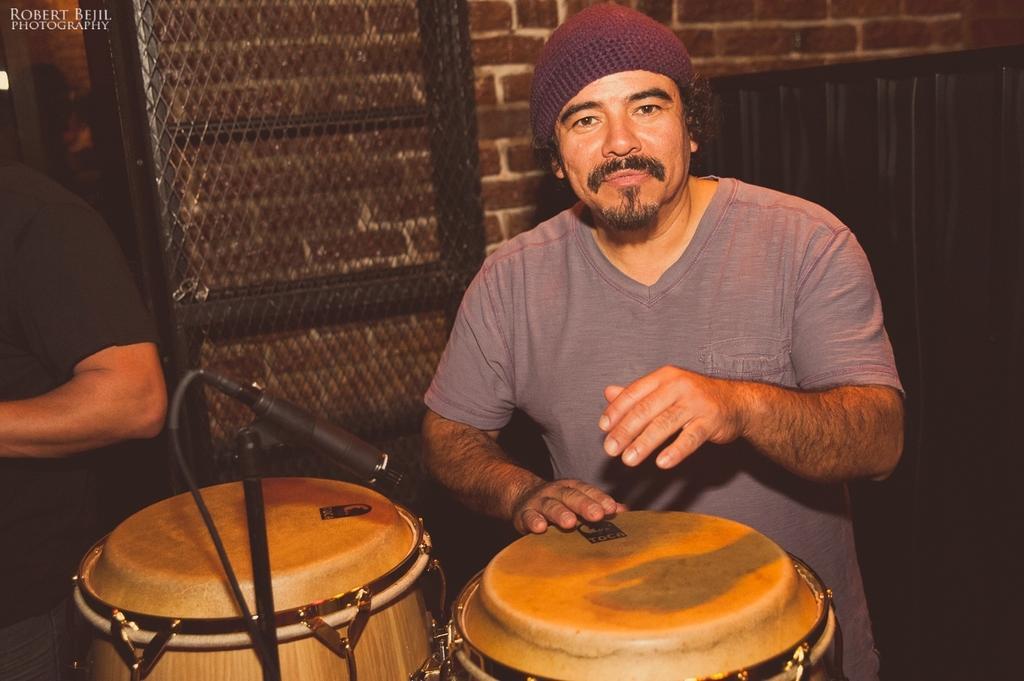Can you describe this image briefly? In this image we can see a person playing musical instruments and a microphone. In the background of the image there is a person, wall, mesh and other objects. On the image there is a watermark. 